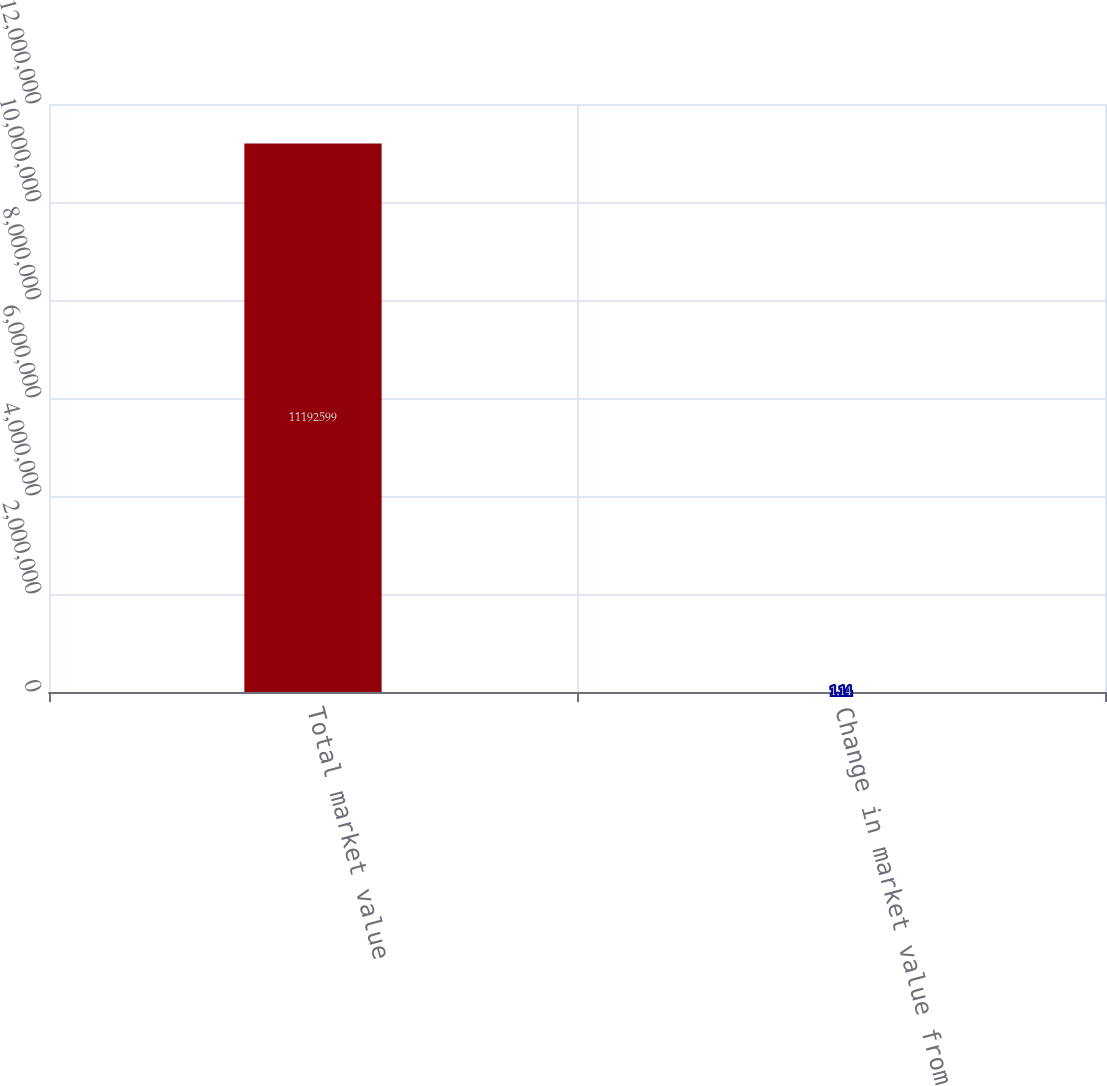<chart> <loc_0><loc_0><loc_500><loc_500><bar_chart><fcel>Total market value<fcel>Change in market value from<nl><fcel>1.11926e+07<fcel>1.14<nl></chart> 